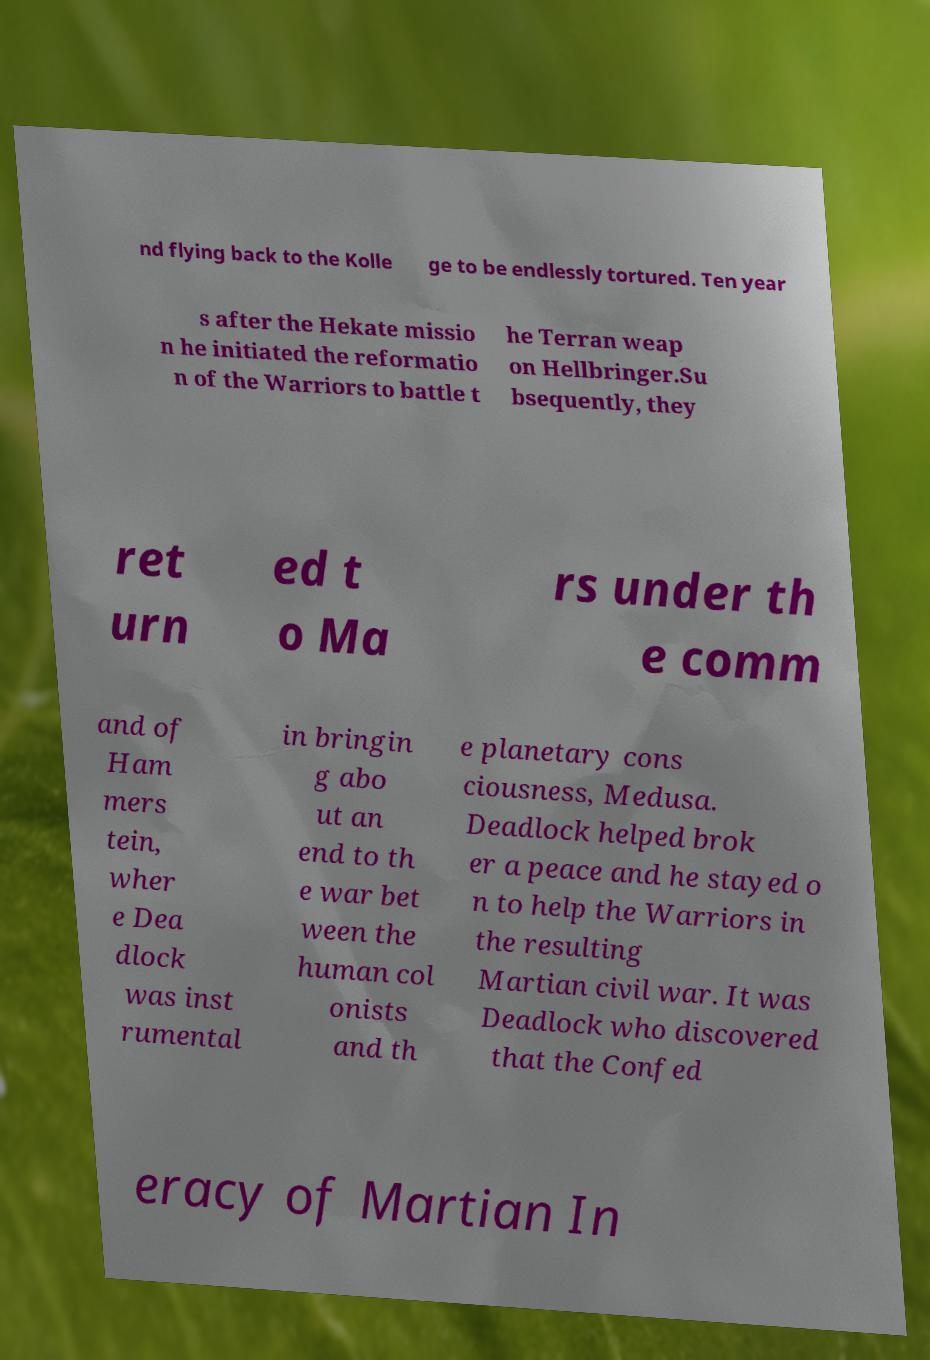Can you read and provide the text displayed in the image?This photo seems to have some interesting text. Can you extract and type it out for me? nd flying back to the Kolle ge to be endlessly tortured. Ten year s after the Hekate missio n he initiated the reformatio n of the Warriors to battle t he Terran weap on Hellbringer.Su bsequently, they ret urn ed t o Ma rs under th e comm and of Ham mers tein, wher e Dea dlock was inst rumental in bringin g abo ut an end to th e war bet ween the human col onists and th e planetary cons ciousness, Medusa. Deadlock helped brok er a peace and he stayed o n to help the Warriors in the resulting Martian civil war. It was Deadlock who discovered that the Confed eracy of Martian In 